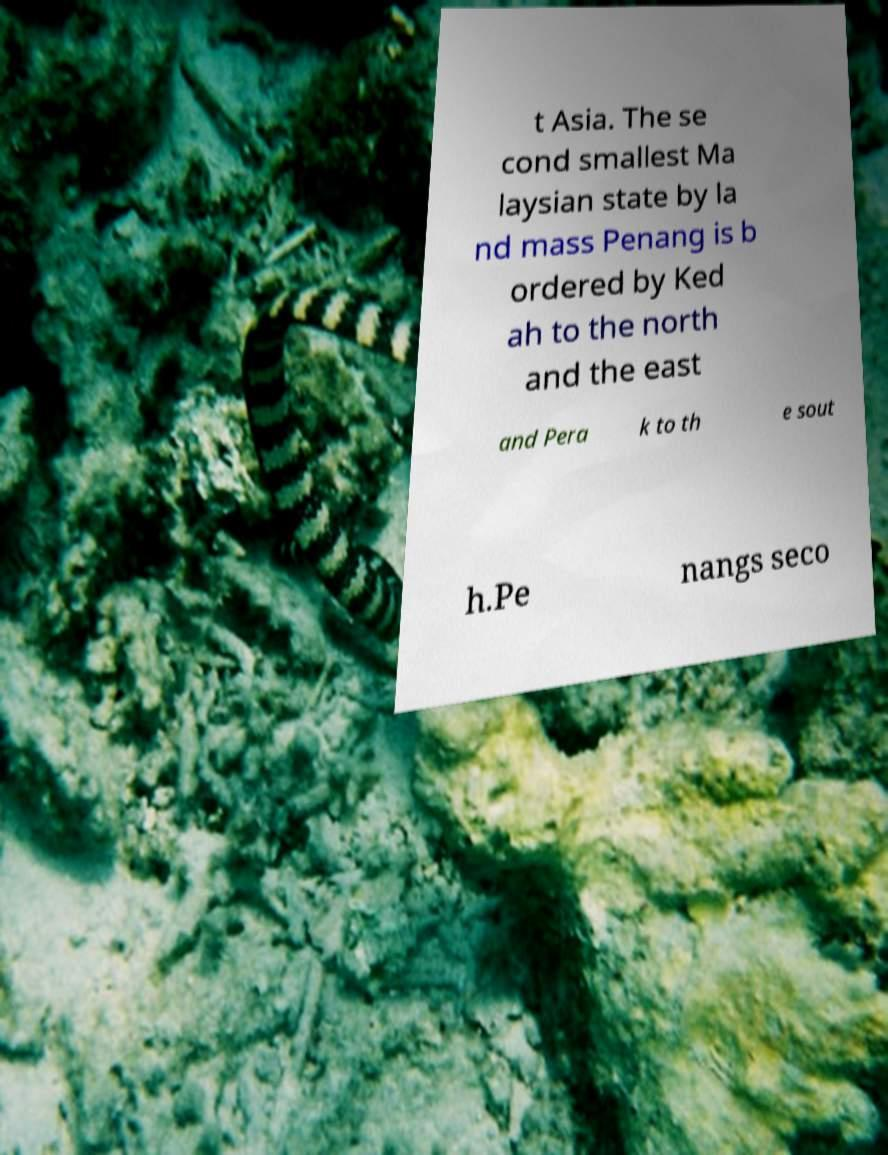I need the written content from this picture converted into text. Can you do that? t Asia. The se cond smallest Ma laysian state by la nd mass Penang is b ordered by Ked ah to the north and the east and Pera k to th e sout h.Pe nangs seco 